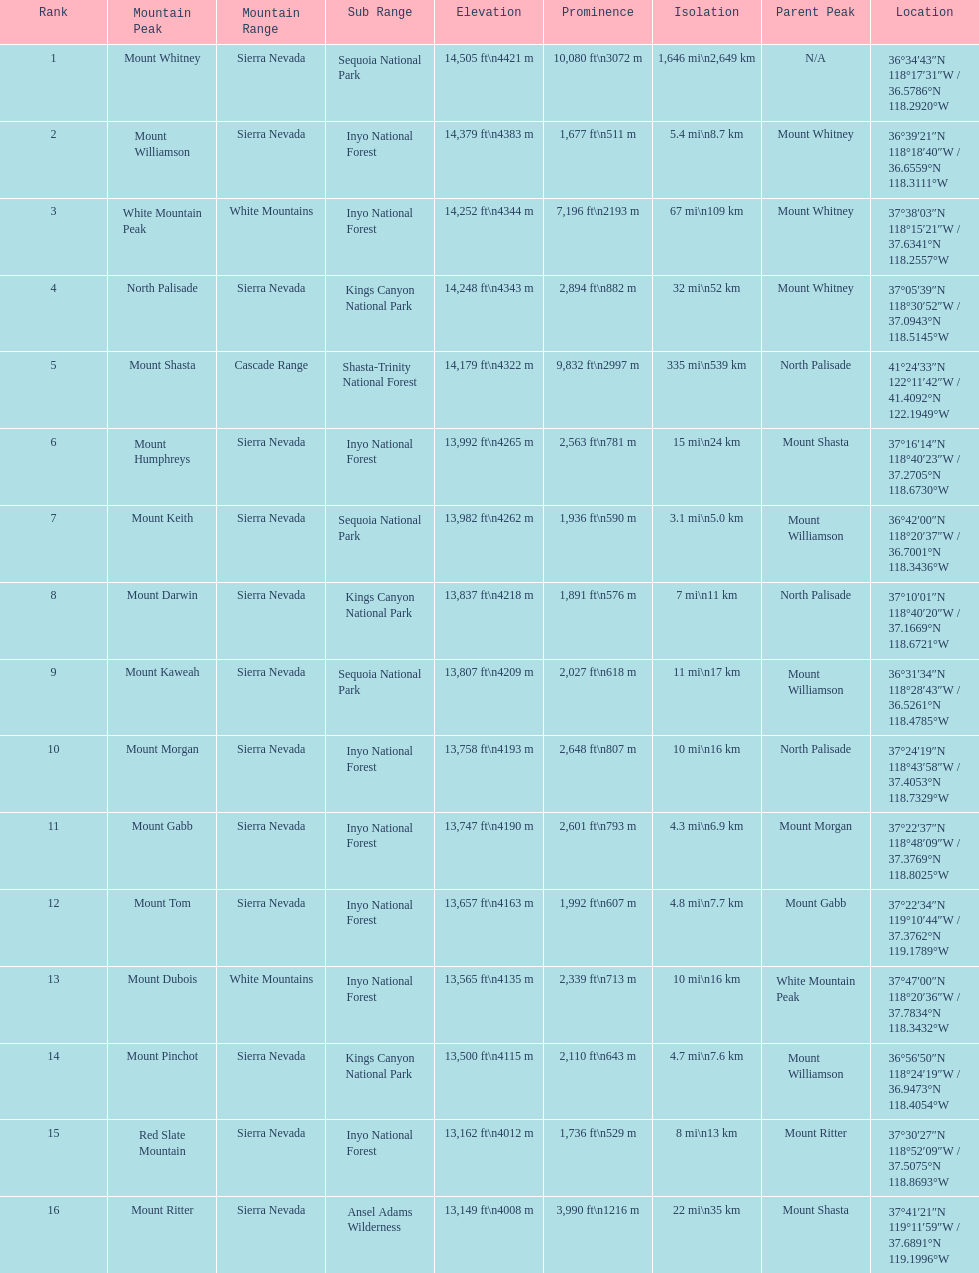What is the only mountain peak listed for the cascade range? Mount Shasta. 